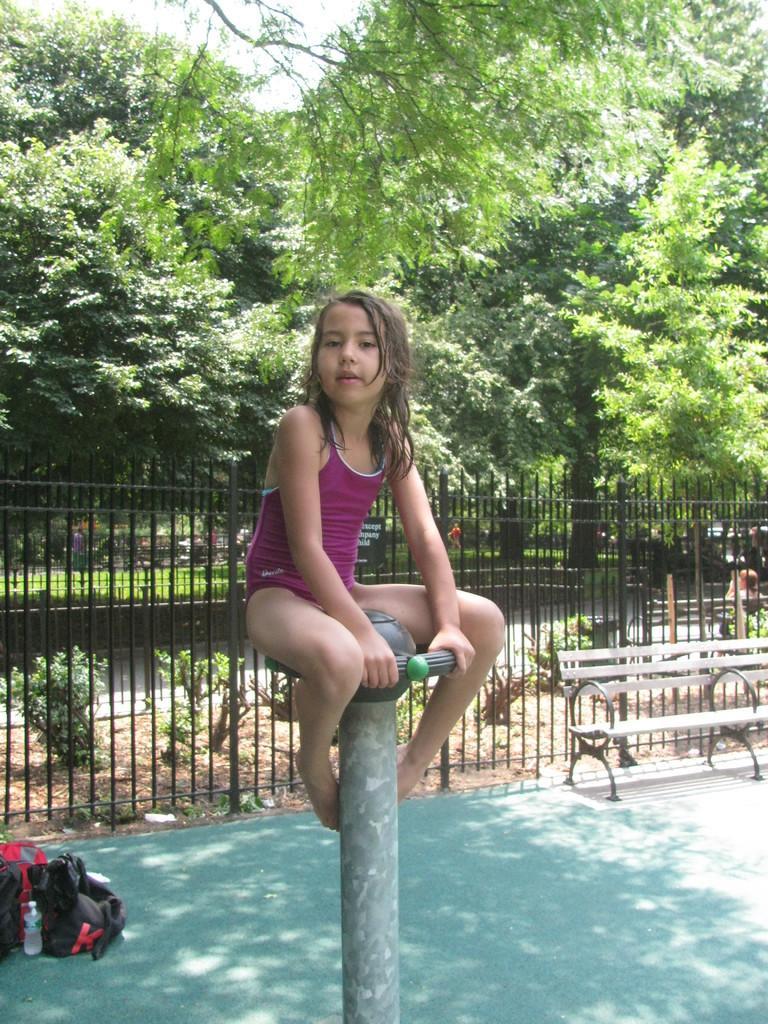Please provide a concise description of this image. In this picture we can observe a girl wearing violet color dress and sitting on this pole. On the left side there are bags and a water bottle. On the right side there is a bench. We can observe black color railing. In the background there are trees. 